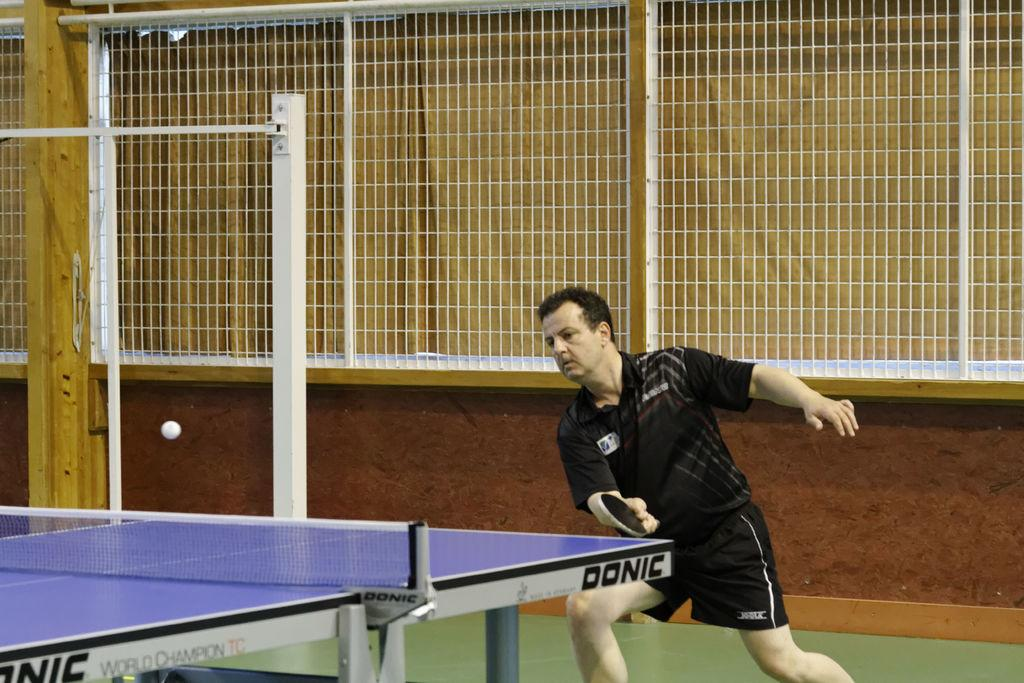What is the main subject of the image? There is a person in the image. What is the person wearing? The person is wearing clothes. What activity is the person engaged in? The person is playing table tennis. What object is the person holding in their hand? The person is holding a bat with their hand. What type of furniture is present in the image? There is a table in the image. What object is being used in the game? There is a ball in the image. What type of string is attached to the person's attention in the image? There is no string or reference to attention in the image; it features a person playing table tennis. 